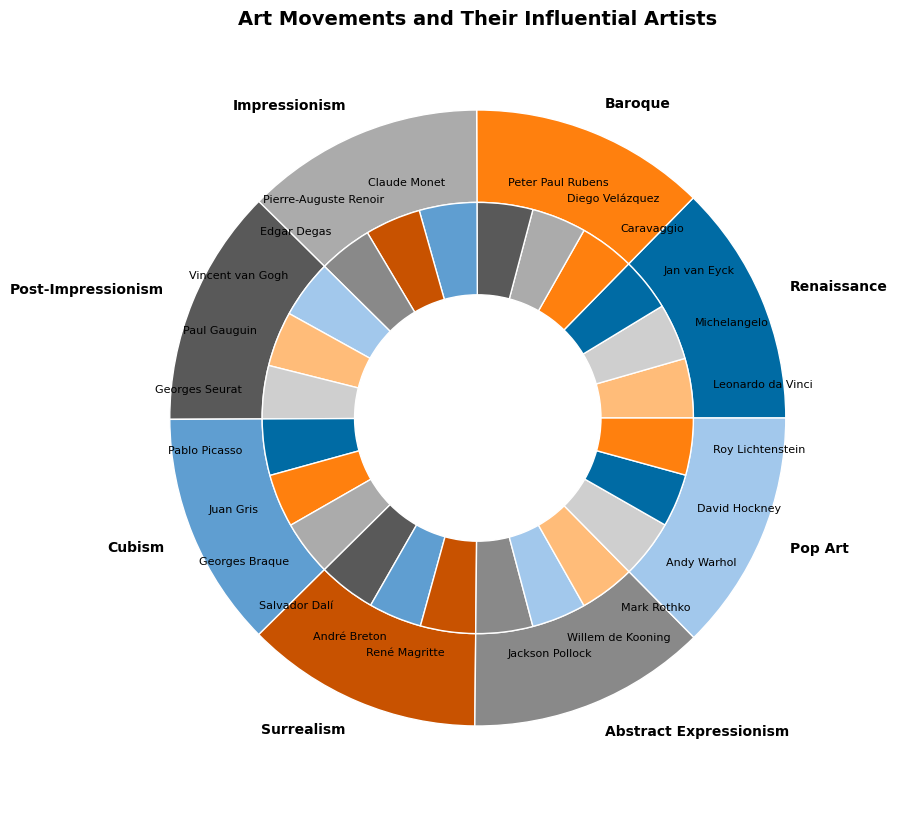Which art movement has the highest overall popularity score? To determine the art movement with the highest overall popularity, look at the outer wedges and their sizes. The largest wedge corresponds to the art movement with the highest total popularity score.
Answer: Renaissance Which artist has the highest popularity score within Impressionism? To find the most popular artist in the Impressionism movement, look at the inner wedges within the Impressionism section of the outer circle and identify the name associated with the largest wedge.
Answer: Claude Monet How does the total popularity score of Cubism compare to Surrealism? Calculate the total popularity scores for Cubism and Surrealism by adding up their respective artists' popularity scores and compare the sums. Cubism (90 + 85 + 88) = 263, Surrealism (92 + 88 + 85) = 265.
Answer: Surrealism is slightly more popular than Cubism In terms of regional influence in the Baroque movement, which region has a higher popularity score, Italy or Flanders? Check the popularity scores of the artists associated with Italy and Flanders in the Baroque movement, then compare the sums: Italy (88) and Flanders (89).
Answer: Flanders Compare the total popularity score of the artists in Post-Impressionism and Abstract Expressionism. Which movement has a higher score? Calculate the total popularity scores for Post-Impressionism (93 + 88 + 85) = 266, and Abstract Expressionism (91 + 87 + 89) = 267, then compare the two.
Answer: Abstract Expressionism Which region appears most frequently in the nested pie chart and how does it impact the visualization of art movements? Identify and count how often each region is represented across all movements. France appears the most frequently (8 times). Its frequent representation means a significant portion of the total area is covered by sections related to France, particularly in movements like Impressionism and Cubism.
Answer: France Looking at the influential artists within the Pop Art movement, which artist's wedge is the largest and what does this reveal about their impact? Find the inner wedges within the Pop Art segment and identify the largest wedge. This corresponds to Andy Warhol, who has the highest popularity score, indicating his significant impact on Pop Art.
Answer: Andy Warhol 